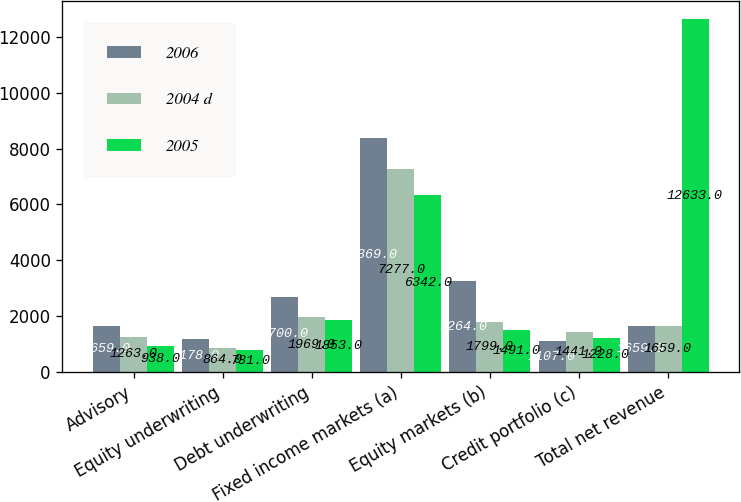Convert chart. <chart><loc_0><loc_0><loc_500><loc_500><stacked_bar_chart><ecel><fcel>Advisory<fcel>Equity underwriting<fcel>Debt underwriting<fcel>Fixed income markets (a)<fcel>Equity markets (b)<fcel>Credit portfolio (c)<fcel>Total net revenue<nl><fcel>2006<fcel>1659<fcel>1178<fcel>2700<fcel>8369<fcel>3264<fcel>1107<fcel>1659<nl><fcel>2004 d<fcel>1263<fcel>864<fcel>1969<fcel>7277<fcel>1799<fcel>1441<fcel>1659<nl><fcel>2005<fcel>938<fcel>781<fcel>1853<fcel>6342<fcel>1491<fcel>1228<fcel>12633<nl></chart> 